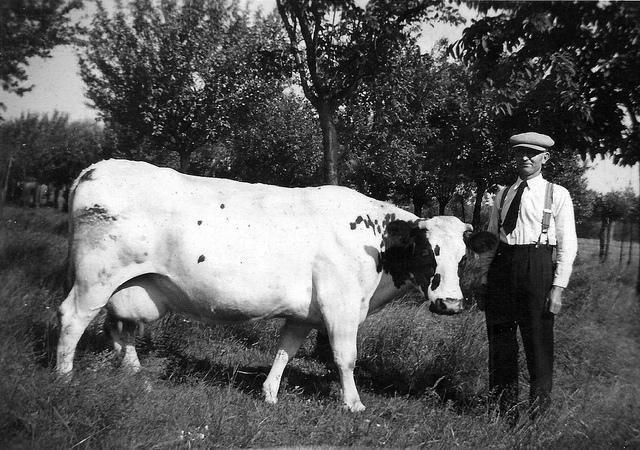How many different vases are there?
Give a very brief answer. 0. 